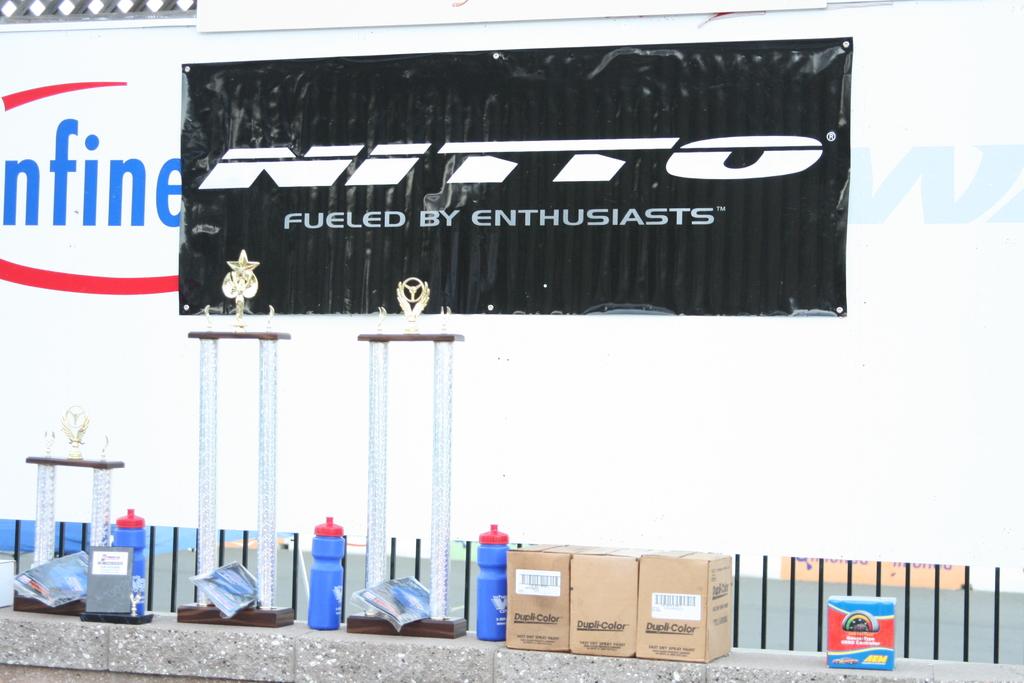What brand is next to nitto?
Offer a very short reply. Nfine. 